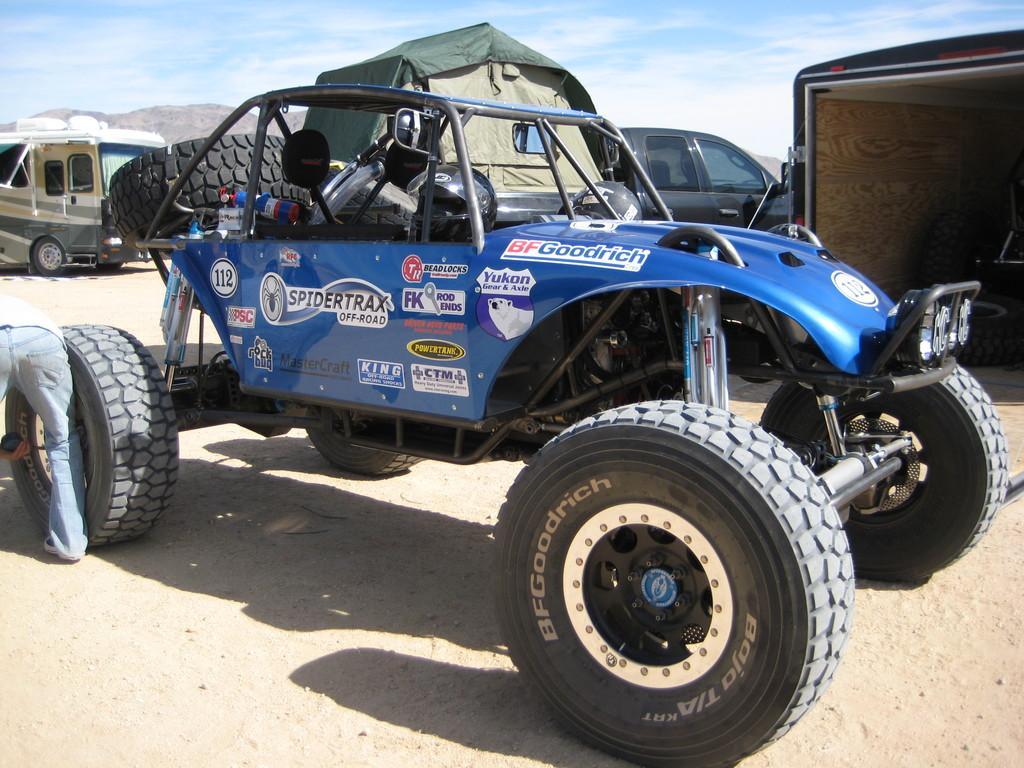How would you summarize this image in a sentence or two? In this image we can see motor vehicles on the ground. In the background there are hills and sky with clouds. 